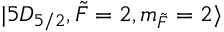Convert formula to latex. <formula><loc_0><loc_0><loc_500><loc_500>| 5 D _ { 5 / 2 } , \tilde { F } = 2 , m _ { \tilde { F } } = 2 \rangle</formula> 